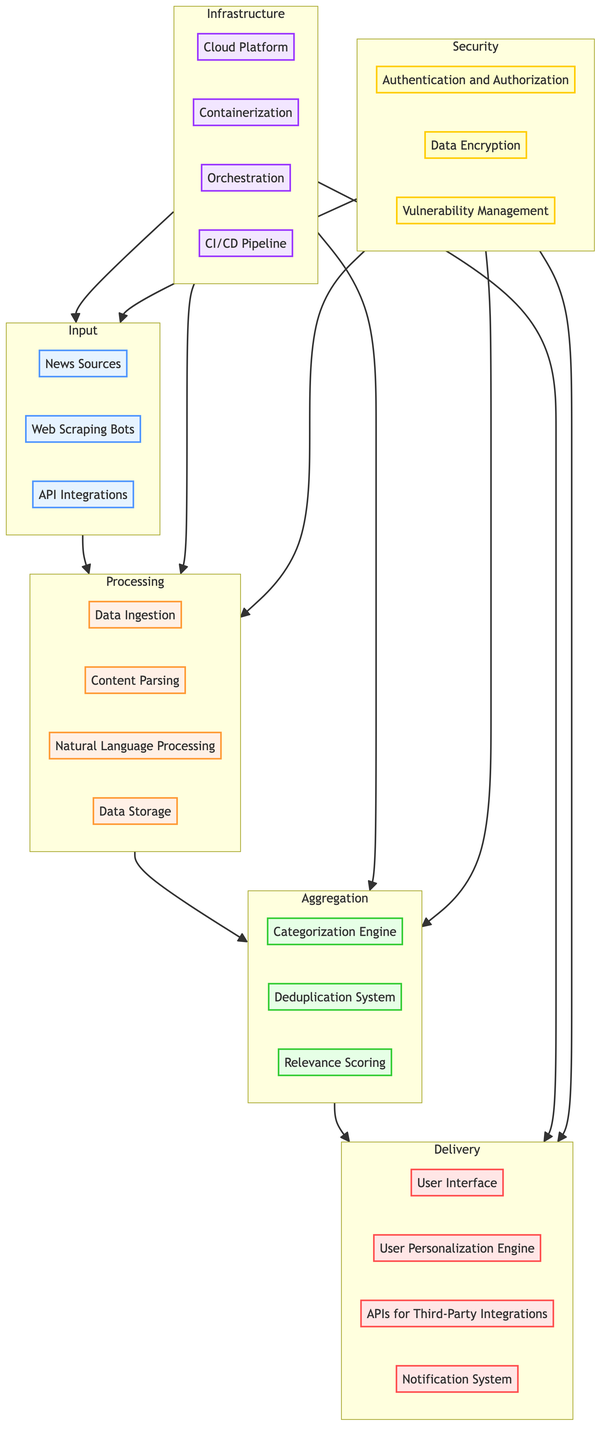What are the input elements of the diagram? The diagram lists several input elements: News Sources, Web Scraping Bots, and API Integrations.
Answer: News Sources, Web Scraping Bots, API Integrations How many processing elements are there? The processing section of the diagram includes four elements: Data Ingestion, Content Parsing, Natural Language Processing, and Data Storage.
Answer: Four What is the connection from Security to Aggregation? The diagram shows a direct link from the Security subgraph to the Aggregation subgraph, indicating that security measures affect the aggregation of news articles.
Answer: Direct link Which element handles the delivery of personalized news? The User Personalization Engine is specified as the element responsible for delivering personalized news.
Answer: User Personalization Engine What element uses machine learning in the diagram? The Categorization Engine is highlighted as the element utilizing machine learning models to categorize news articles.
Answer: Categorization Engine How many elements are in the Delivery section? The Delivery section contains four elements: User Interface, User Personalization Engine, APIs for Third-Party Integrations, and Notification System.
Answer: Four Explain the flow from Input to Delivery. The flow begins at the Input section, where news is collected. It then moves to Processing, where the data is ingested and parsed. Next, it goes to Aggregation for categorization and relevance scoring. Finally, it ends at Delivery, where the news is presented to users.
Answer: Input → Processing → Aggregation → Delivery What technologies are mentioned in the Infrastructure subgraph? The Infrastructure subgraph details four technologies: Cloud Platform, Containerization, Orchestration, and CI/CD Pipeline.
Answer: Cloud Platform, Containerization, Orchestration, CI/CD Pipeline What does the Data Encryption element ensure? Data Encryption ensures the protection of data in transit and at rest through the use of SSL/TLS and AES technologies.
Answer: Protection of data How many nodes are present in the Aggregation section? The Aggregation section has three specific nodes: Categorization Engine, Deduplication System, and Relevance Scoring.
Answer: Three 